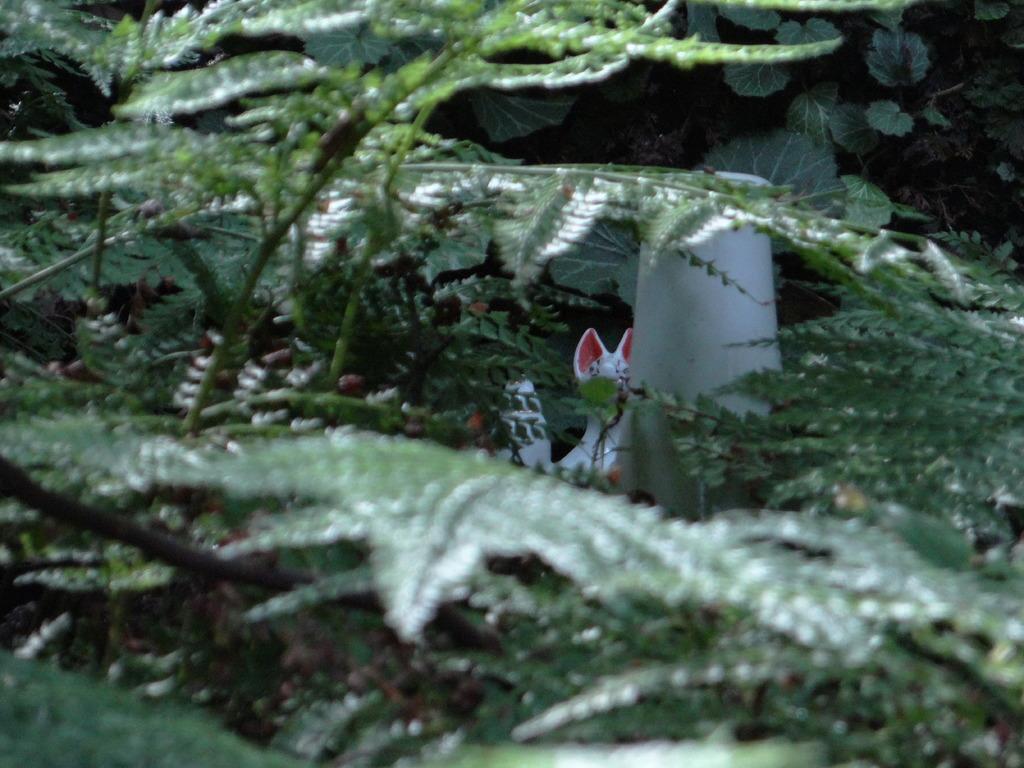In one or two sentences, can you explain what this image depicts? In this image we can see trees and leaves. 